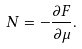Convert formula to latex. <formula><loc_0><loc_0><loc_500><loc_500>N = - \frac { \partial F } { \partial \mu } .</formula> 